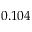<formula> <loc_0><loc_0><loc_500><loc_500>0 . 1 0 4</formula> 